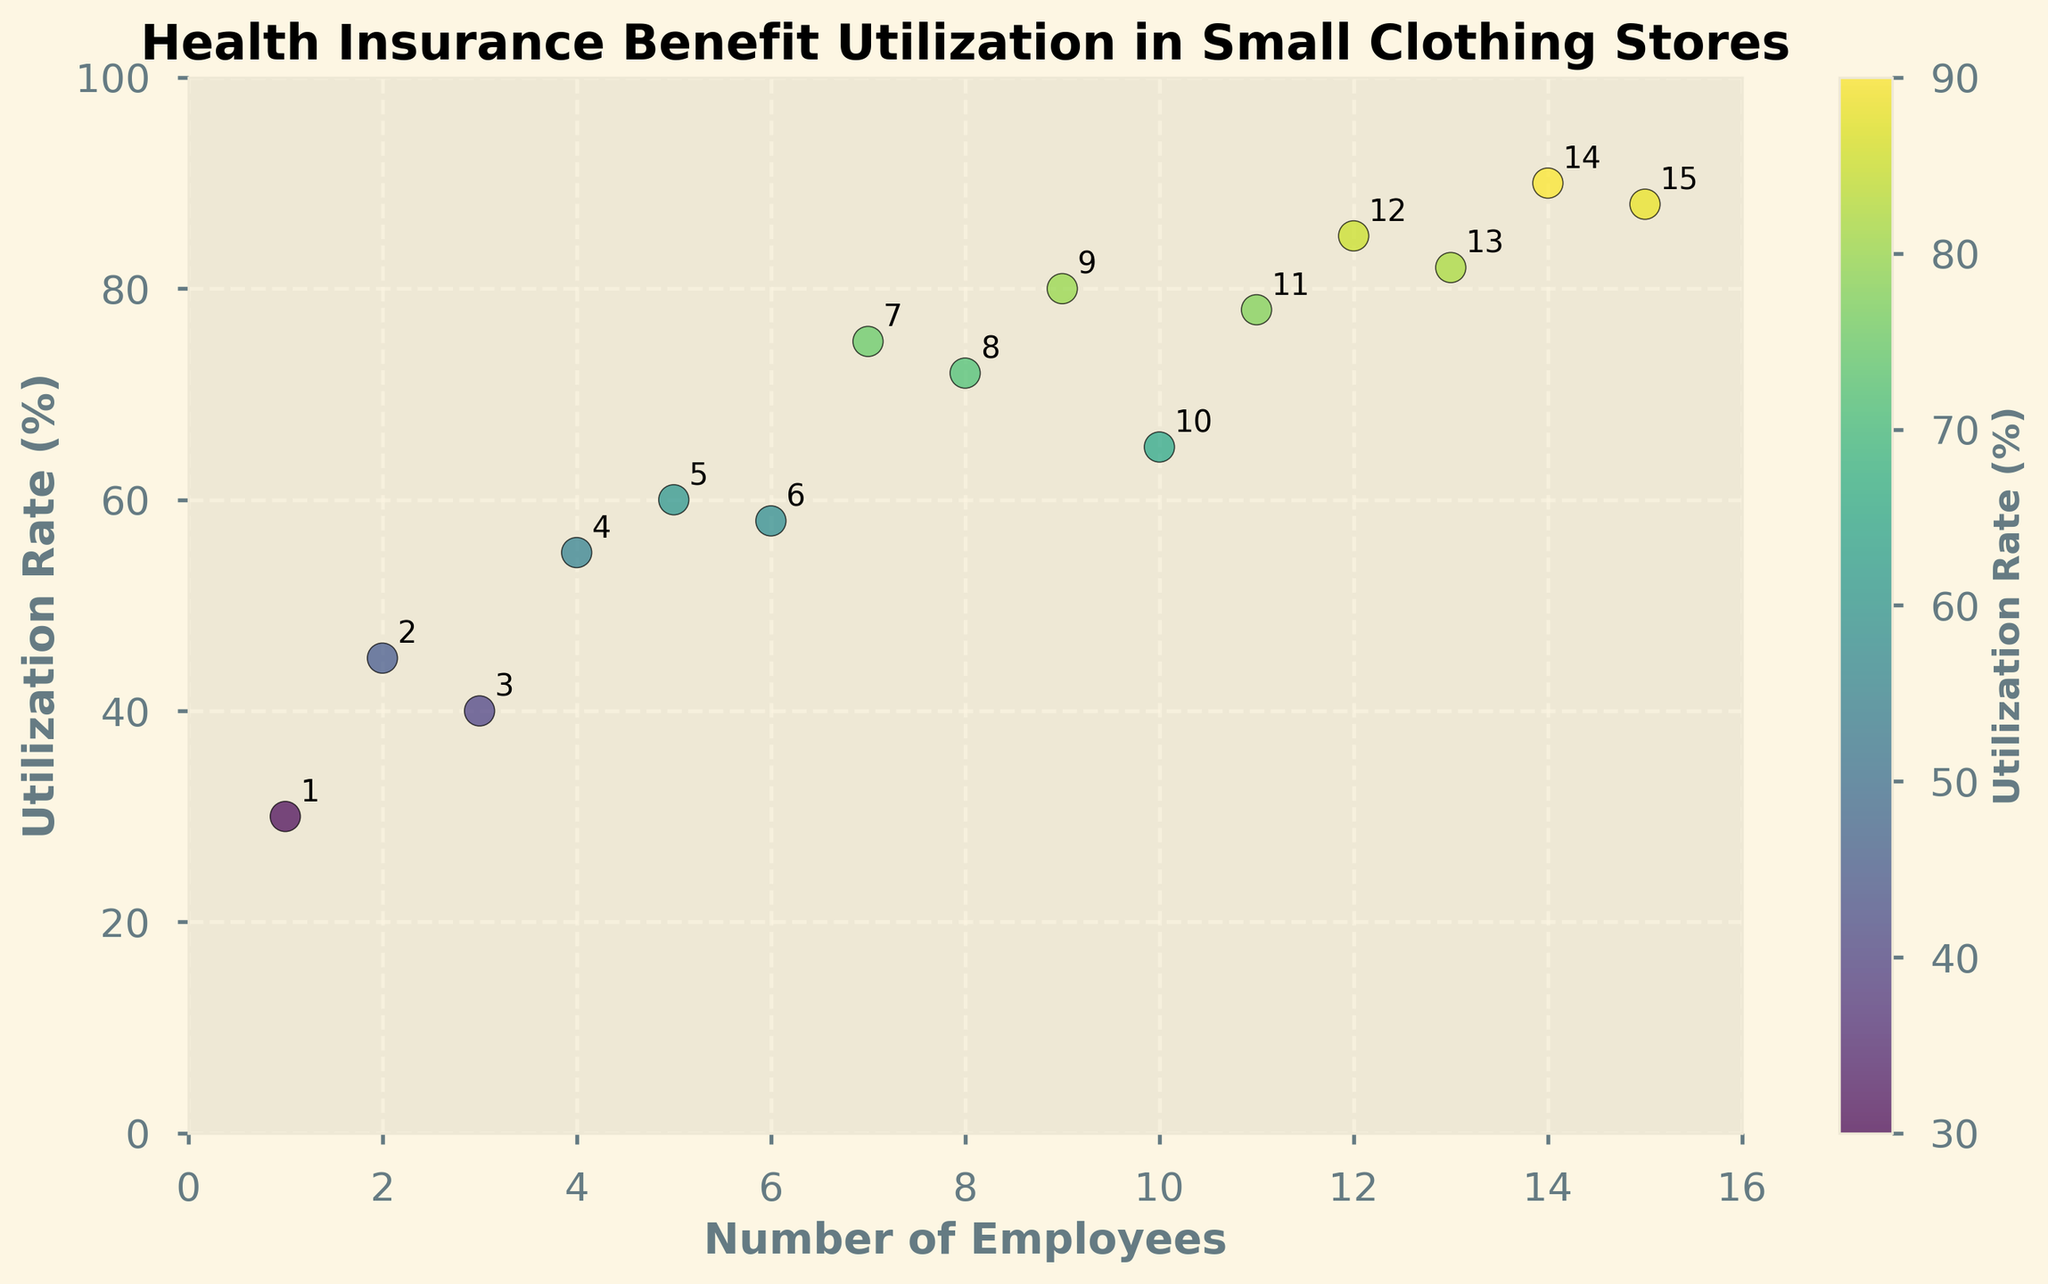What's the title of the plot? The title is displayed at the top center of the plot and reads "Health Insurance Benefit Utilization in Small Clothing Stores".
Answer: Health Insurance Benefit Utilization in Small Clothing Stores What are the x-axis and y-axis labels? The x-axis label is at the bottom of the plot, and it reads "Number of Employees". The y-axis label is on the left side of the plot, and it reads "Utilization Rate (%)".
Answer: Number of Employees, Utilization Rate (%) How many data points are shown in the plot? Each data point represents an employee count and its corresponding utilization rate. Counting the number of points on the plot shows a total of 15 data points.
Answer: 15 What's the utilization rate when there are 10 employees? Locate where the x-value is 10. The y-value (utilization rate) at that point is marked as 65%.
Answer: 65% Which employee count has the highest utilization rate and what is that rate? The highest utilization rate is found by looking for the highest y-value on the scatter plot. The point with the maximum y-value is at an employee count of 14, with a utilization rate of 90%.
Answer: 14 employees, 90% Is there a general trend between the number of employees and the utilization rate? Examine the overall positioning of the points. The scatter plot shows a general increasing trend, meaning that as the number of employees increases, the utilization rate tends to increase as well.
Answer: Increasing trend What's the average utilization rate for employee counts between 5 and 10 (inclusive)? Identify the points where the employee count is between 5 and 10: (5, 60), (6, 58), (7, 75), (8, 72), (9, 80), and (10, 65). Add the utilization rates: 60 + 58 + 75 + 72 + 80 + 65 = 410. Divide this sum by the number of points (6): 410 / 6 ≈ 68.33.
Answer: 68.33% What is the color range indicating on the scatter plot? The color range is indicated by the color bar on the right side of the plot. It represents different utilization rates, with different colors ranging from lower to higher utilization rates.
Answer: Utilization Rate (%) For which employee count(s) is the utilization rate exactly above 80%? Look at points where the y-value (utilization rate) exceeds 80%. These points are at employee counts of 11 (78%), 12 (85%), 13 (82%), 14 (90%), and 15 (88%).
Answer: 12, 13, 14, 15 What’s the average number of employees when the utilization rate is greater than 70%? Identify points with utilization rates above 70%: (7, 75), (8, 72), (9, 80), (10, 65), (11, 78), (12, 85), (13, 82), (14, 90), (15, 88). The counts are 7, 8, 9, 11, 12, 13, 14, and 15, for average calculation: (7 + 8 + 9 + 11 + 12 + 13 + 14 + 15) / 8 = 89 / 8 = 11.125.
Answer: 11.125 